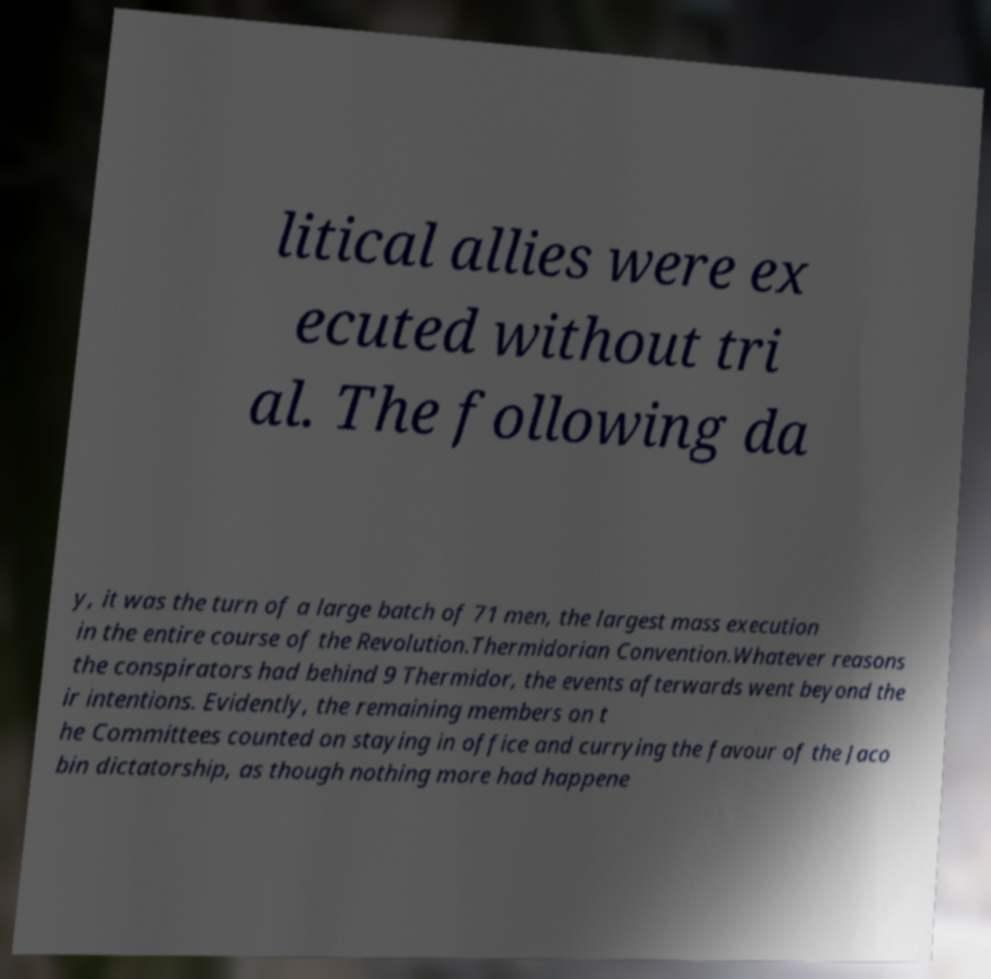Please read and relay the text visible in this image. What does it say? litical allies were ex ecuted without tri al. The following da y, it was the turn of a large batch of 71 men, the largest mass execution in the entire course of the Revolution.Thermidorian Convention.Whatever reasons the conspirators had behind 9 Thermidor, the events afterwards went beyond the ir intentions. Evidently, the remaining members on t he Committees counted on staying in office and currying the favour of the Jaco bin dictatorship, as though nothing more had happene 